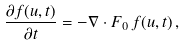Convert formula to latex. <formula><loc_0><loc_0><loc_500><loc_500>\frac { \partial f ( u , t ) } { \partial t } = - \nabla \cdot F _ { 0 } \, f ( u , t ) \, ,</formula> 